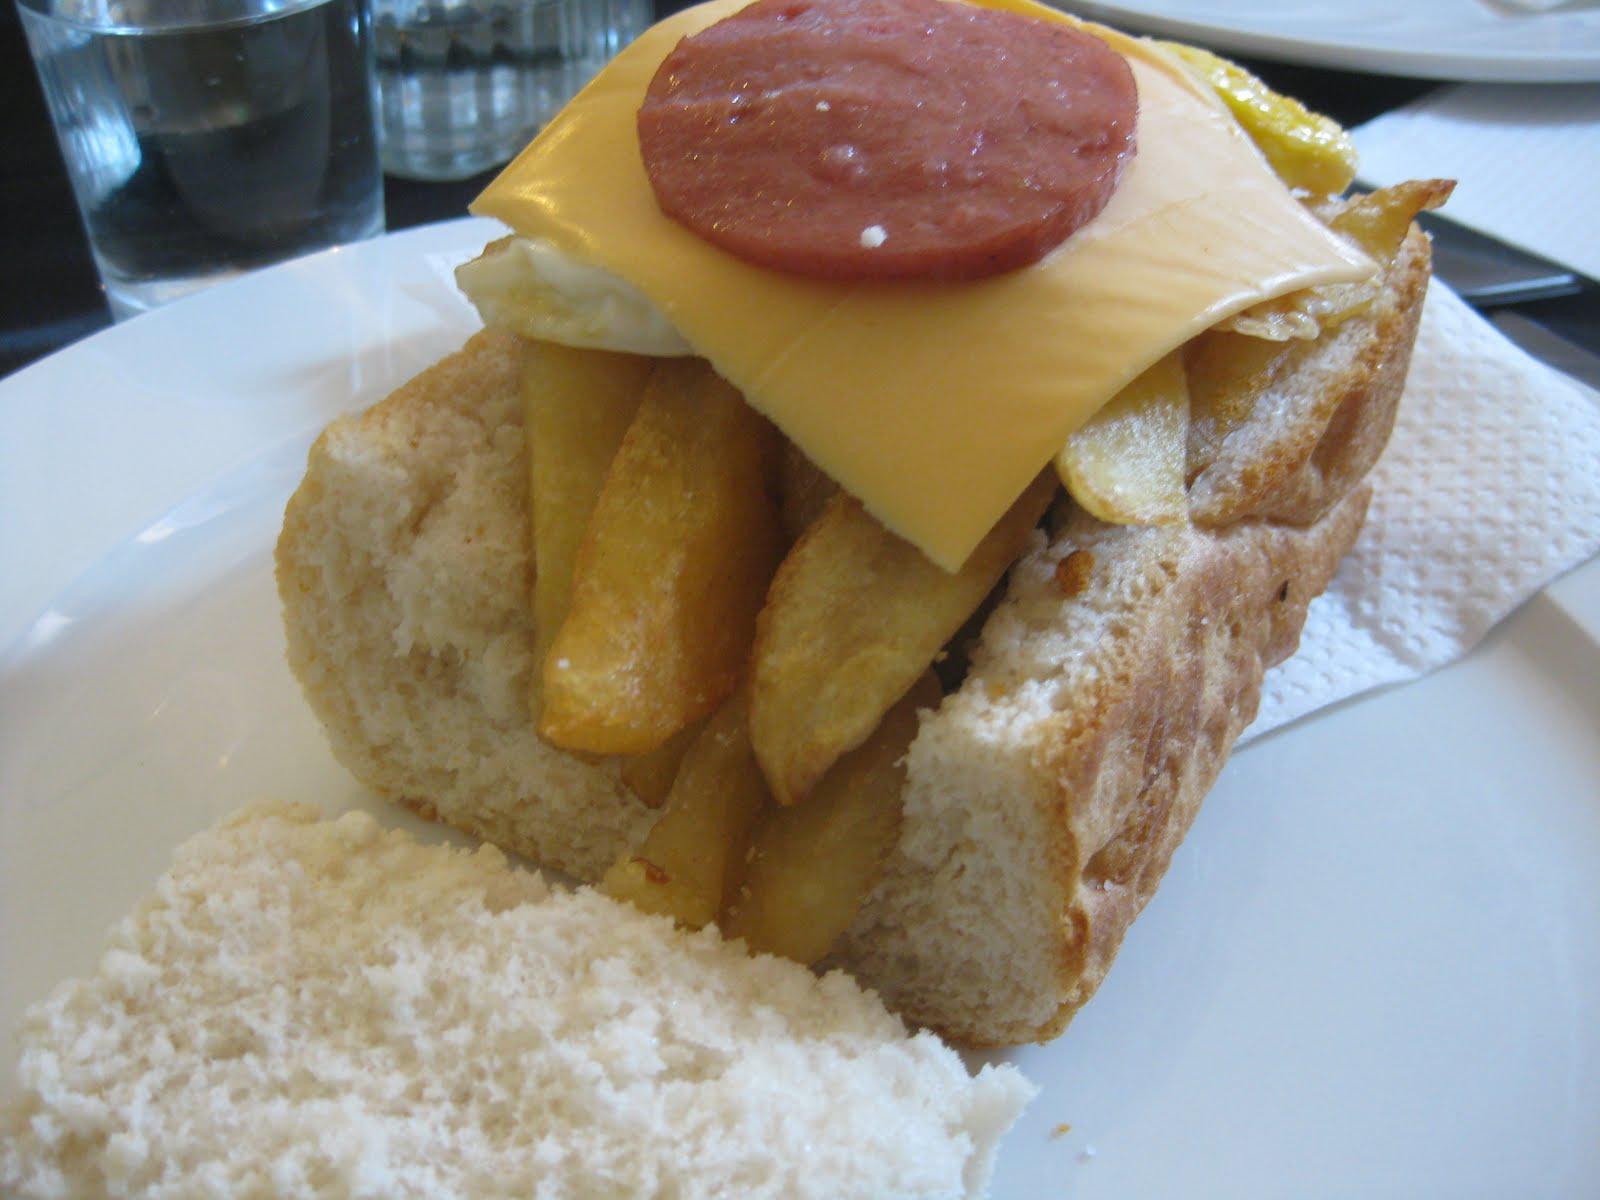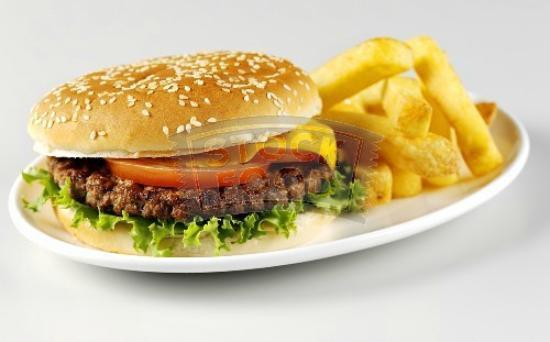The first image is the image on the left, the second image is the image on the right. Examine the images to the left and right. Is the description "One of the items contains lettuce." accurate? Answer yes or no. Yes. The first image is the image on the left, the second image is the image on the right. Evaluate the accuracy of this statement regarding the images: "The left image shows a sandwich with contents that include french fries, cheese and a round slice of meat stacked on bread.". Is it true? Answer yes or no. Yes. 